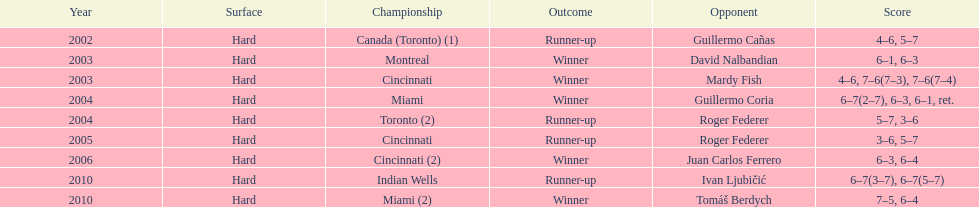I'm looking to parse the entire table for insights. Could you assist me with that? {'header': ['Year', 'Surface', 'Championship', 'Outcome', 'Opponent', 'Score'], 'rows': [['2002', 'Hard', 'Canada (Toronto) (1)', 'Runner-up', 'Guillermo Cañas', '4–6, 5–7'], ['2003', 'Hard', 'Montreal', 'Winner', 'David Nalbandian', '6–1, 6–3'], ['2003', 'Hard', 'Cincinnati', 'Winner', 'Mardy Fish', '4–6, 7–6(7–3), 7–6(7–4)'], ['2004', 'Hard', 'Miami', 'Winner', 'Guillermo Coria', '6–7(2–7), 6–3, 6–1, ret.'], ['2004', 'Hard', 'Toronto (2)', 'Runner-up', 'Roger Federer', '5–7, 3–6'], ['2005', 'Hard', 'Cincinnati', 'Runner-up', 'Roger Federer', '3–6, 5–7'], ['2006', 'Hard', 'Cincinnati (2)', 'Winner', 'Juan Carlos Ferrero', '6–3, 6–4'], ['2010', 'Hard', 'Indian Wells', 'Runner-up', 'Ivan Ljubičić', '6–7(3–7), 6–7(5–7)'], ['2010', 'Hard', 'Miami (2)', 'Winner', 'Tomáš Berdych', '7–5, 6–4']]} What was the highest number of consecutive wins? 3. 